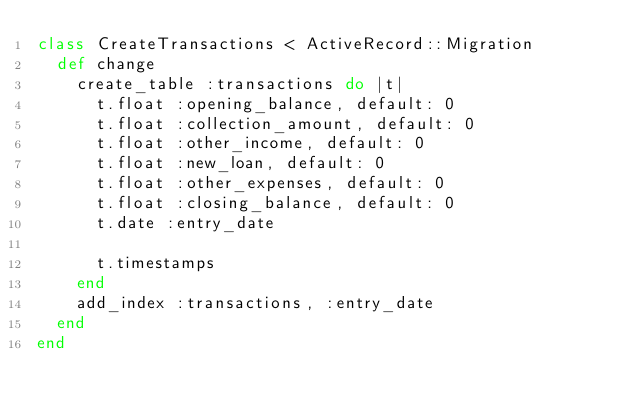<code> <loc_0><loc_0><loc_500><loc_500><_Ruby_>class CreateTransactions < ActiveRecord::Migration
  def change
    create_table :transactions do |t|
      t.float :opening_balance, default: 0
      t.float :collection_amount, default: 0
      t.float :other_income, default: 0
      t.float :new_loan, default: 0
      t.float :other_expenses, default: 0
      t.float :closing_balance, default: 0
      t.date :entry_date

      t.timestamps
    end
    add_index :transactions, :entry_date
  end
end
</code> 